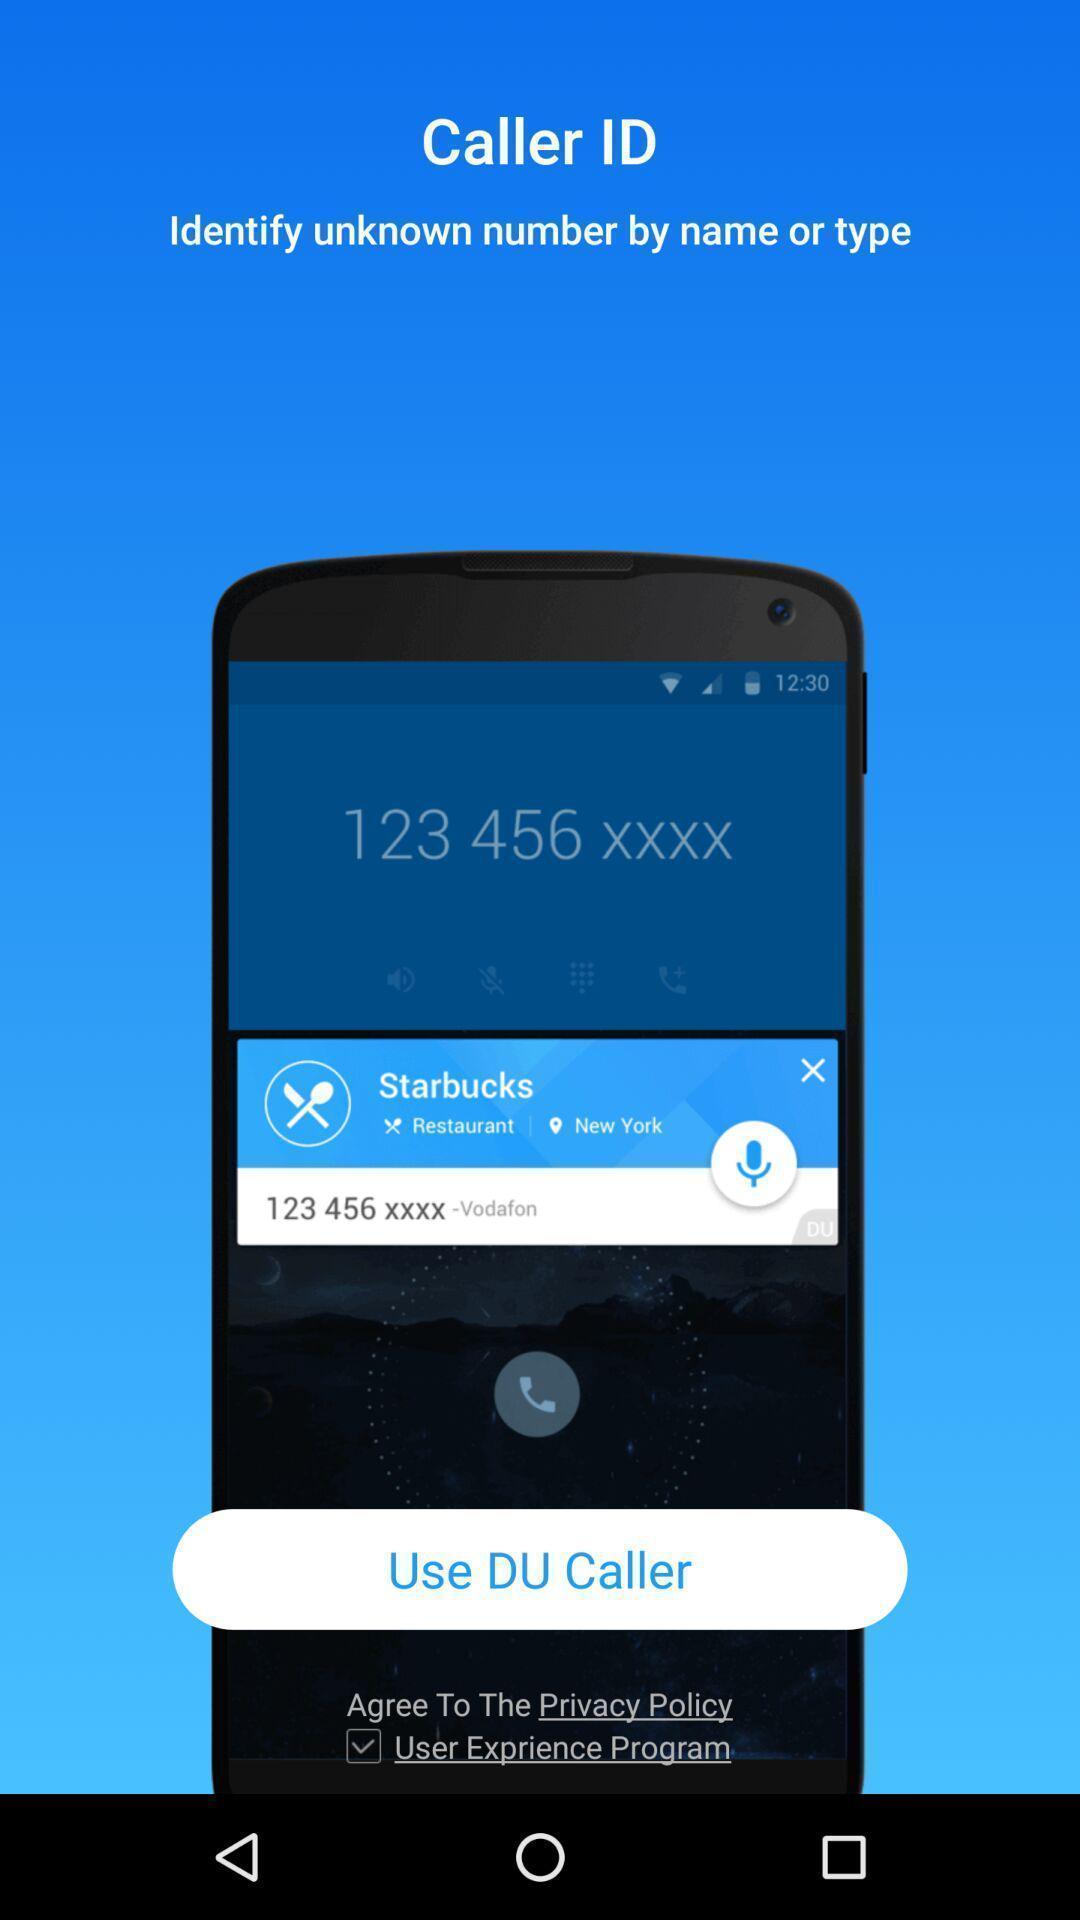Provide a detailed account of this screenshot. Welcome page of a calling app. 